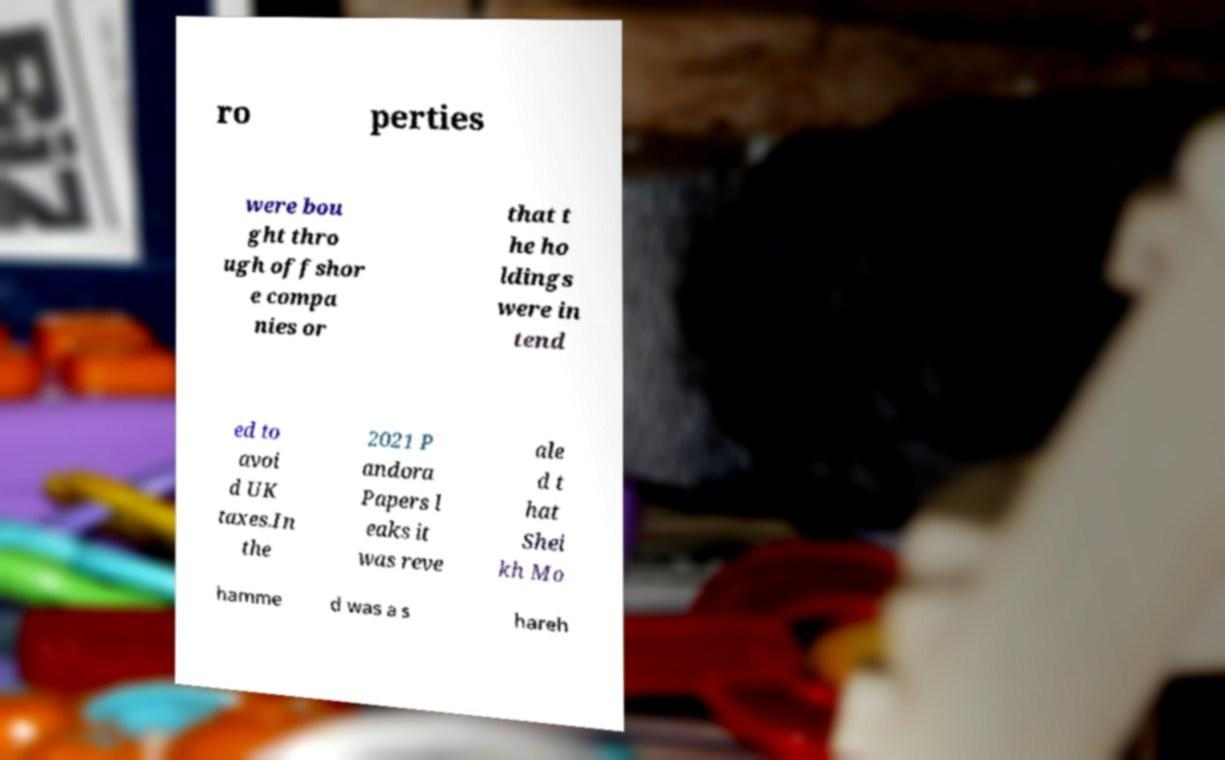Can you accurately transcribe the text from the provided image for me? ro perties were bou ght thro ugh offshor e compa nies or that t he ho ldings were in tend ed to avoi d UK taxes.In the 2021 P andora Papers l eaks it was reve ale d t hat Shei kh Mo hamme d was a s hareh 